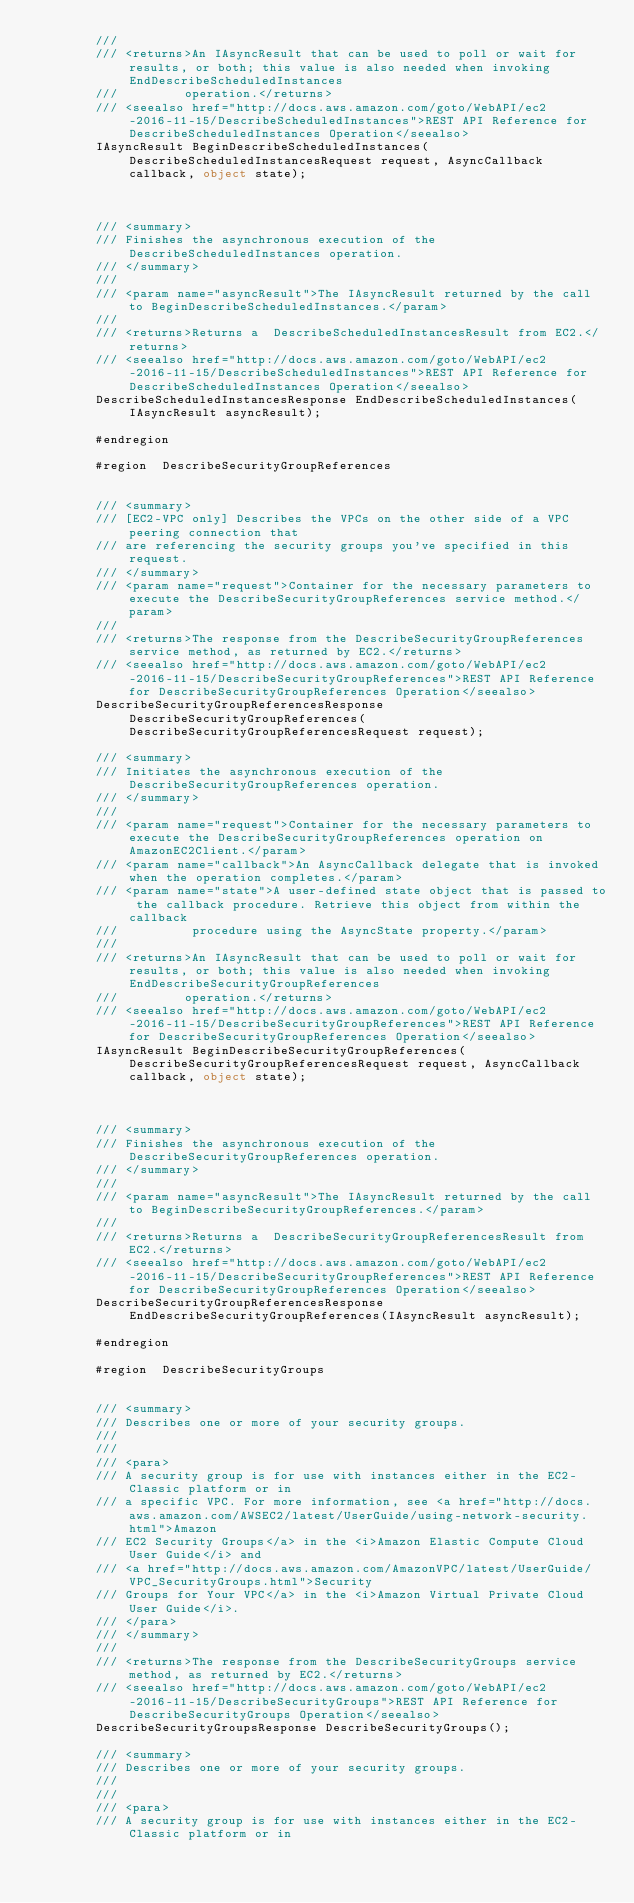<code> <loc_0><loc_0><loc_500><loc_500><_C#_>        /// 
        /// <returns>An IAsyncResult that can be used to poll or wait for results, or both; this value is also needed when invoking EndDescribeScheduledInstances
        ///         operation.</returns>
        /// <seealso href="http://docs.aws.amazon.com/goto/WebAPI/ec2-2016-11-15/DescribeScheduledInstances">REST API Reference for DescribeScheduledInstances Operation</seealso>
        IAsyncResult BeginDescribeScheduledInstances(DescribeScheduledInstancesRequest request, AsyncCallback callback, object state);



        /// <summary>
        /// Finishes the asynchronous execution of the  DescribeScheduledInstances operation.
        /// </summary>
        /// 
        /// <param name="asyncResult">The IAsyncResult returned by the call to BeginDescribeScheduledInstances.</param>
        /// 
        /// <returns>Returns a  DescribeScheduledInstancesResult from EC2.</returns>
        /// <seealso href="http://docs.aws.amazon.com/goto/WebAPI/ec2-2016-11-15/DescribeScheduledInstances">REST API Reference for DescribeScheduledInstances Operation</seealso>
        DescribeScheduledInstancesResponse EndDescribeScheduledInstances(IAsyncResult asyncResult);

        #endregion
        
        #region  DescribeSecurityGroupReferences


        /// <summary>
        /// [EC2-VPC only] Describes the VPCs on the other side of a VPC peering connection that
        /// are referencing the security groups you've specified in this request.
        /// </summary>
        /// <param name="request">Container for the necessary parameters to execute the DescribeSecurityGroupReferences service method.</param>
        /// 
        /// <returns>The response from the DescribeSecurityGroupReferences service method, as returned by EC2.</returns>
        /// <seealso href="http://docs.aws.amazon.com/goto/WebAPI/ec2-2016-11-15/DescribeSecurityGroupReferences">REST API Reference for DescribeSecurityGroupReferences Operation</seealso>
        DescribeSecurityGroupReferencesResponse DescribeSecurityGroupReferences(DescribeSecurityGroupReferencesRequest request);

        /// <summary>
        /// Initiates the asynchronous execution of the DescribeSecurityGroupReferences operation.
        /// </summary>
        /// 
        /// <param name="request">Container for the necessary parameters to execute the DescribeSecurityGroupReferences operation on AmazonEC2Client.</param>
        /// <param name="callback">An AsyncCallback delegate that is invoked when the operation completes.</param>
        /// <param name="state">A user-defined state object that is passed to the callback procedure. Retrieve this object from within the callback
        ///          procedure using the AsyncState property.</param>
        /// 
        /// <returns>An IAsyncResult that can be used to poll or wait for results, or both; this value is also needed when invoking EndDescribeSecurityGroupReferences
        ///         operation.</returns>
        /// <seealso href="http://docs.aws.amazon.com/goto/WebAPI/ec2-2016-11-15/DescribeSecurityGroupReferences">REST API Reference for DescribeSecurityGroupReferences Operation</seealso>
        IAsyncResult BeginDescribeSecurityGroupReferences(DescribeSecurityGroupReferencesRequest request, AsyncCallback callback, object state);



        /// <summary>
        /// Finishes the asynchronous execution of the  DescribeSecurityGroupReferences operation.
        /// </summary>
        /// 
        /// <param name="asyncResult">The IAsyncResult returned by the call to BeginDescribeSecurityGroupReferences.</param>
        /// 
        /// <returns>Returns a  DescribeSecurityGroupReferencesResult from EC2.</returns>
        /// <seealso href="http://docs.aws.amazon.com/goto/WebAPI/ec2-2016-11-15/DescribeSecurityGroupReferences">REST API Reference for DescribeSecurityGroupReferences Operation</seealso>
        DescribeSecurityGroupReferencesResponse EndDescribeSecurityGroupReferences(IAsyncResult asyncResult);

        #endregion
        
        #region  DescribeSecurityGroups


        /// <summary>
        /// Describes one or more of your security groups.
        /// 
        ///  
        /// <para>
        /// A security group is for use with instances either in the EC2-Classic platform or in
        /// a specific VPC. For more information, see <a href="http://docs.aws.amazon.com/AWSEC2/latest/UserGuide/using-network-security.html">Amazon
        /// EC2 Security Groups</a> in the <i>Amazon Elastic Compute Cloud User Guide</i> and
        /// <a href="http://docs.aws.amazon.com/AmazonVPC/latest/UserGuide/VPC_SecurityGroups.html">Security
        /// Groups for Your VPC</a> in the <i>Amazon Virtual Private Cloud User Guide</i>.
        /// </para>
        /// </summary>
        /// 
        /// <returns>The response from the DescribeSecurityGroups service method, as returned by EC2.</returns>
        /// <seealso href="http://docs.aws.amazon.com/goto/WebAPI/ec2-2016-11-15/DescribeSecurityGroups">REST API Reference for DescribeSecurityGroups Operation</seealso>
        DescribeSecurityGroupsResponse DescribeSecurityGroups();

        /// <summary>
        /// Describes one or more of your security groups.
        /// 
        ///  
        /// <para>
        /// A security group is for use with instances either in the EC2-Classic platform or in</code> 